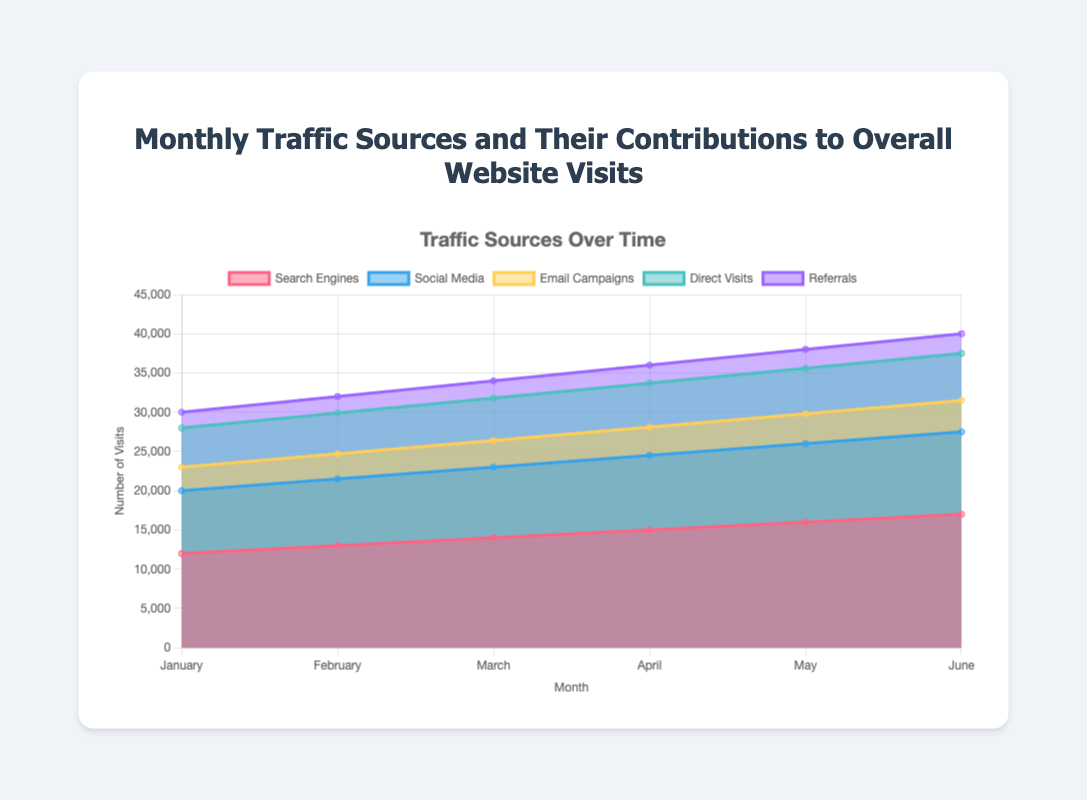what is the title of the area chart? The title of the chart can be found at the top and is typically the largest text. It reads "Monthly Traffic Sources and Their Contributions to Overall Website Visits."
Answer: Monthly Traffic Sources and Their Contributions to Overall Website Visits How many months of data are displayed on the x-axis? The x-axis represents the months, and we can count the number of labels: January, February, March, April, May, and June. This gives us 6 months of data.
Answer: 6 Which traffic source had the highest number of visits in June? To find the highest number of visits in June, look for the tallest area segment above the "June" label on the x-axis. The color-coded section with the most significant height is the light red, representing Search Engines.
Answer: Search Engines What is the cumulative number of visits for Email Campaigns over all months? To find this, sum up the number of visits for Email Campaigns from January to June: 3000 + 3200 + 3400 + 3600 + 3800 + 4000 = 21000.
Answer: 21000 In which month did Social Media traffic increase the most compared to the previous month? Look at the change in the height of the blue area (Social Media) month by month. From January to February, the increase is 500 (8500 - 8000); from February to March, it is 500 (9000 - 8500); from March to April, it is 500 (9500 - 9000); from April to May, it is 500 (10000 - 9500); and from May to June, it is 500 (10500 - 10000). The increase is the same each month.
Answer: Every month has an equal increase of 500 visits Which month had the lowest total website visits? The lowest total can be identified by the smallest combined height of all the different colors in an area chart. January has the smallest combined height for all traffic sources.
Answer: January What is the difference in total visits between the month with the highest and the lowest visits? Identify the highest total (June: 41000) and the lowest (January: 30000). The difference is 41000 - 30000 = 11000.
Answer: 11000 By how much did the visits due to Direct Visits increase from January to June? The number of visits from Direct Visits in January is 5000 and in June is 6000. The increase is 6000 - 5000 = 1000.
Answer: 1000 How does the contribution of Referrals compare to Direct Visits across the months? On average, Referrals (purple area) consistently contribute less than Direct Visits (green area) when visually comparing their areas over each month.
Answer: Referrals contribute less Which traffic source showed the most consistent growth across all months? Examine the area representing each traffic source month by month. Search Engines (light red area) show a steady, linear increase from January to June.
Answer: Search Engines 